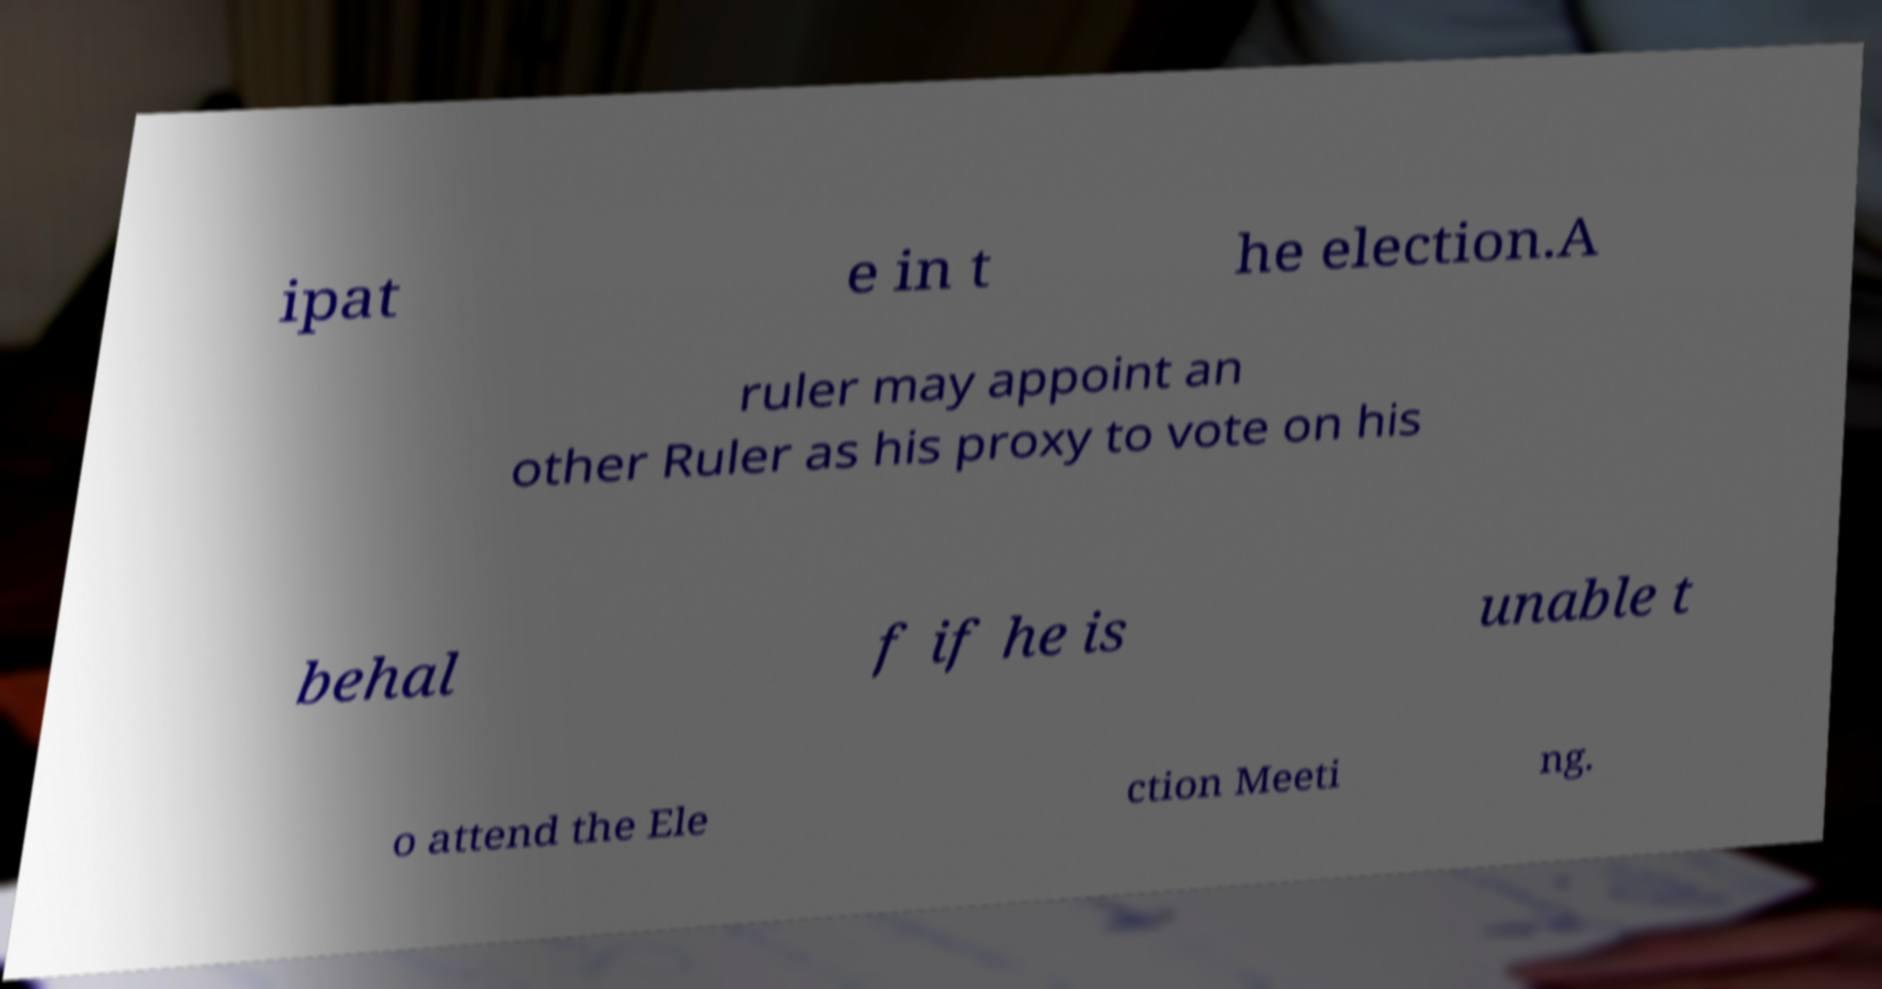What messages or text are displayed in this image? I need them in a readable, typed format. ipat e in t he election.A ruler may appoint an other Ruler as his proxy to vote on his behal f if he is unable t o attend the Ele ction Meeti ng. 